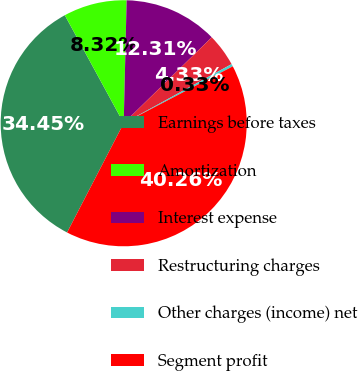Convert chart. <chart><loc_0><loc_0><loc_500><loc_500><pie_chart><fcel>Earnings before taxes<fcel>Amortization<fcel>Interest expense<fcel>Restructuring charges<fcel>Other charges (income) net<fcel>Segment profit<nl><fcel>34.45%<fcel>8.32%<fcel>12.31%<fcel>4.33%<fcel>0.33%<fcel>40.26%<nl></chart> 